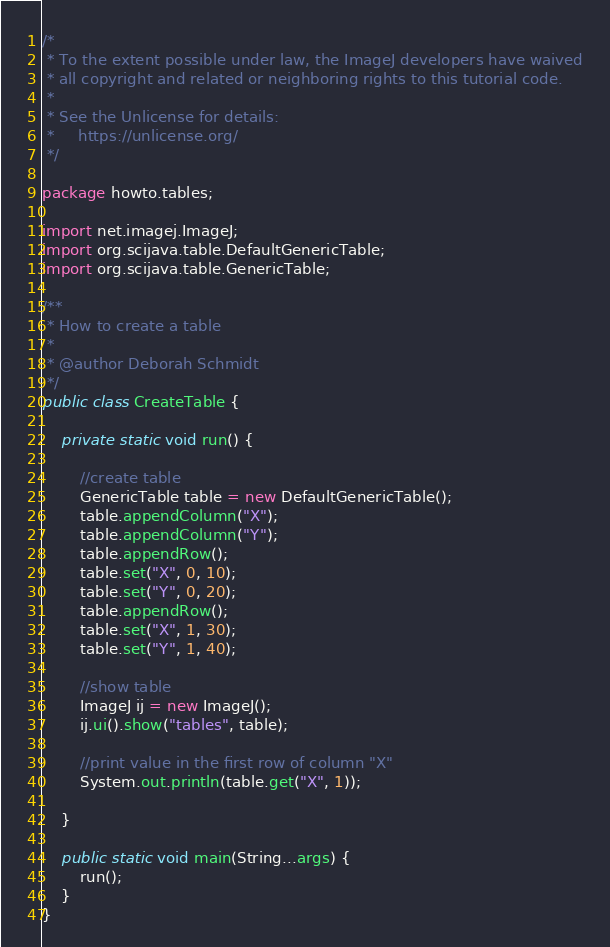<code> <loc_0><loc_0><loc_500><loc_500><_Java_>/*
 * To the extent possible under law, the ImageJ developers have waived
 * all copyright and related or neighboring rights to this tutorial code.
 *
 * See the Unlicense for details:
 *     https://unlicense.org/
 */

package howto.tables;

import net.imagej.ImageJ;
import org.scijava.table.DefaultGenericTable;
import org.scijava.table.GenericTable;

/**
 * How to create a table
 *
 * @author Deborah Schmidt
 */
public class CreateTable {

	private static void run() {

		//create table
		GenericTable table = new DefaultGenericTable();
		table.appendColumn("X");
		table.appendColumn("Y");
		table.appendRow();
		table.set("X", 0, 10);
		table.set("Y", 0, 20);
		table.appendRow();
		table.set("X", 1, 30);
		table.set("Y", 1, 40);

		//show table
		ImageJ ij = new ImageJ();
		ij.ui().show("tables", table);

		//print value in the first row of column "X"
		System.out.println(table.get("X", 1));

	}

	public static void main(String...args) {
		run();
	}
}
</code> 